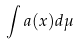<formula> <loc_0><loc_0><loc_500><loc_500>\int a ( x ) d \mu</formula> 